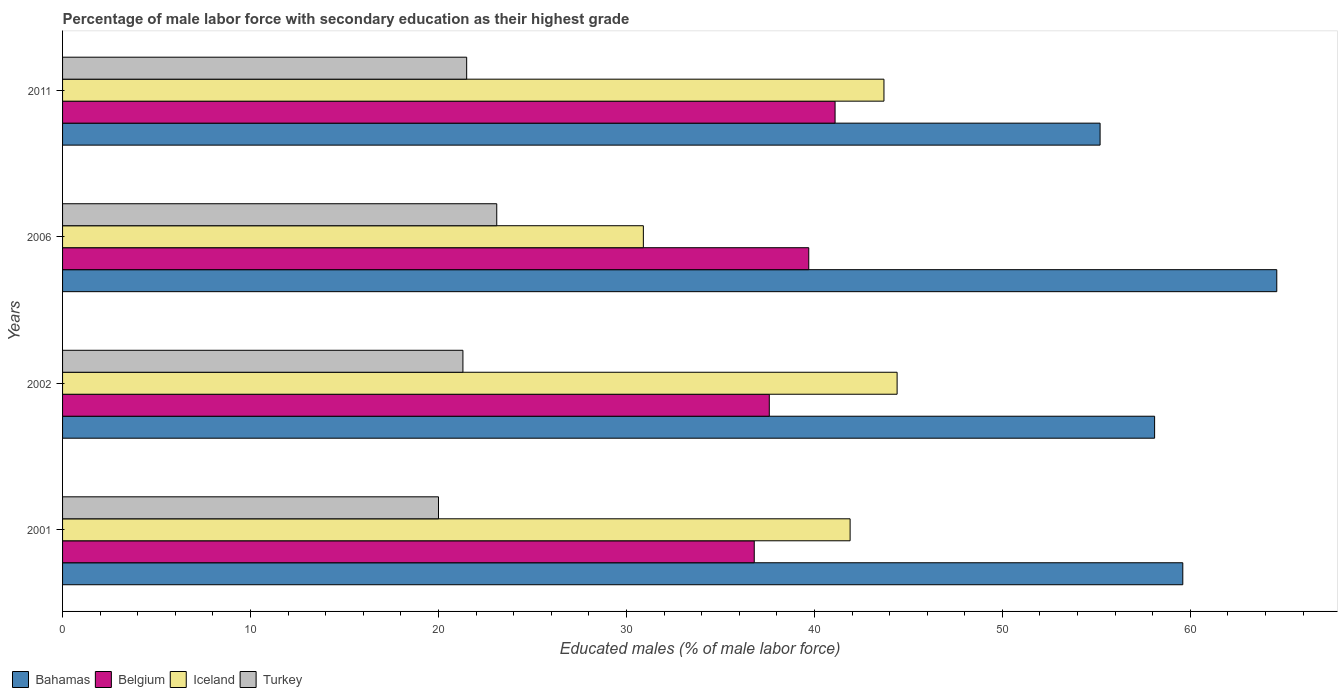Are the number of bars on each tick of the Y-axis equal?
Make the answer very short. Yes. How many bars are there on the 2nd tick from the top?
Offer a very short reply. 4. What is the percentage of male labor force with secondary education in Bahamas in 2011?
Your answer should be very brief. 55.2. Across all years, what is the maximum percentage of male labor force with secondary education in Belgium?
Provide a succinct answer. 41.1. What is the total percentage of male labor force with secondary education in Belgium in the graph?
Provide a succinct answer. 155.2. What is the difference between the percentage of male labor force with secondary education in Bahamas in 2001 and that in 2011?
Ensure brevity in your answer.  4.4. What is the difference between the percentage of male labor force with secondary education in Bahamas in 2006 and the percentage of male labor force with secondary education in Belgium in 2011?
Your answer should be compact. 23.5. What is the average percentage of male labor force with secondary education in Belgium per year?
Offer a terse response. 38.8. In the year 2001, what is the difference between the percentage of male labor force with secondary education in Bahamas and percentage of male labor force with secondary education in Turkey?
Make the answer very short. 39.6. In how many years, is the percentage of male labor force with secondary education in Iceland greater than 8 %?
Offer a very short reply. 4. What is the ratio of the percentage of male labor force with secondary education in Bahamas in 2001 to that in 2006?
Your answer should be compact. 0.92. Is the percentage of male labor force with secondary education in Iceland in 2001 less than that in 2006?
Your answer should be very brief. No. Is the difference between the percentage of male labor force with secondary education in Bahamas in 2006 and 2011 greater than the difference between the percentage of male labor force with secondary education in Turkey in 2006 and 2011?
Your answer should be very brief. Yes. What is the difference between the highest and the second highest percentage of male labor force with secondary education in Iceland?
Your response must be concise. 0.7. What is the difference between the highest and the lowest percentage of male labor force with secondary education in Bahamas?
Keep it short and to the point. 9.4. In how many years, is the percentage of male labor force with secondary education in Belgium greater than the average percentage of male labor force with secondary education in Belgium taken over all years?
Your answer should be compact. 2. What does the 3rd bar from the top in 2006 represents?
Your answer should be compact. Belgium. What does the 1st bar from the bottom in 2011 represents?
Ensure brevity in your answer.  Bahamas. How many bars are there?
Ensure brevity in your answer.  16. Are all the bars in the graph horizontal?
Give a very brief answer. Yes. What is the difference between two consecutive major ticks on the X-axis?
Make the answer very short. 10. Are the values on the major ticks of X-axis written in scientific E-notation?
Your answer should be compact. No. Does the graph contain grids?
Ensure brevity in your answer.  No. Where does the legend appear in the graph?
Ensure brevity in your answer.  Bottom left. What is the title of the graph?
Offer a terse response. Percentage of male labor force with secondary education as their highest grade. What is the label or title of the X-axis?
Your response must be concise. Educated males (% of male labor force). What is the label or title of the Y-axis?
Give a very brief answer. Years. What is the Educated males (% of male labor force) of Bahamas in 2001?
Your response must be concise. 59.6. What is the Educated males (% of male labor force) of Belgium in 2001?
Provide a short and direct response. 36.8. What is the Educated males (% of male labor force) of Iceland in 2001?
Ensure brevity in your answer.  41.9. What is the Educated males (% of male labor force) in Turkey in 2001?
Make the answer very short. 20. What is the Educated males (% of male labor force) of Bahamas in 2002?
Offer a terse response. 58.1. What is the Educated males (% of male labor force) in Belgium in 2002?
Make the answer very short. 37.6. What is the Educated males (% of male labor force) of Iceland in 2002?
Your response must be concise. 44.4. What is the Educated males (% of male labor force) in Turkey in 2002?
Offer a terse response. 21.3. What is the Educated males (% of male labor force) in Bahamas in 2006?
Give a very brief answer. 64.6. What is the Educated males (% of male labor force) of Belgium in 2006?
Ensure brevity in your answer.  39.7. What is the Educated males (% of male labor force) of Iceland in 2006?
Make the answer very short. 30.9. What is the Educated males (% of male labor force) of Turkey in 2006?
Make the answer very short. 23.1. What is the Educated males (% of male labor force) in Bahamas in 2011?
Your response must be concise. 55.2. What is the Educated males (% of male labor force) of Belgium in 2011?
Your answer should be compact. 41.1. What is the Educated males (% of male labor force) in Iceland in 2011?
Give a very brief answer. 43.7. Across all years, what is the maximum Educated males (% of male labor force) of Bahamas?
Keep it short and to the point. 64.6. Across all years, what is the maximum Educated males (% of male labor force) in Belgium?
Keep it short and to the point. 41.1. Across all years, what is the maximum Educated males (% of male labor force) in Iceland?
Your answer should be compact. 44.4. Across all years, what is the maximum Educated males (% of male labor force) in Turkey?
Your answer should be compact. 23.1. Across all years, what is the minimum Educated males (% of male labor force) of Bahamas?
Keep it short and to the point. 55.2. Across all years, what is the minimum Educated males (% of male labor force) in Belgium?
Offer a very short reply. 36.8. Across all years, what is the minimum Educated males (% of male labor force) of Iceland?
Keep it short and to the point. 30.9. What is the total Educated males (% of male labor force) of Bahamas in the graph?
Your response must be concise. 237.5. What is the total Educated males (% of male labor force) of Belgium in the graph?
Offer a very short reply. 155.2. What is the total Educated males (% of male labor force) in Iceland in the graph?
Give a very brief answer. 160.9. What is the total Educated males (% of male labor force) in Turkey in the graph?
Your answer should be compact. 85.9. What is the difference between the Educated males (% of male labor force) of Belgium in 2001 and that in 2002?
Provide a short and direct response. -0.8. What is the difference between the Educated males (% of male labor force) in Iceland in 2001 and that in 2002?
Your response must be concise. -2.5. What is the difference between the Educated males (% of male labor force) in Belgium in 2001 and that in 2006?
Your response must be concise. -2.9. What is the difference between the Educated males (% of male labor force) of Iceland in 2001 and that in 2006?
Provide a short and direct response. 11. What is the difference between the Educated males (% of male labor force) in Iceland in 2001 and that in 2011?
Provide a short and direct response. -1.8. What is the difference between the Educated males (% of male labor force) of Belgium in 2002 and that in 2006?
Your response must be concise. -2.1. What is the difference between the Educated males (% of male labor force) of Iceland in 2002 and that in 2006?
Your answer should be very brief. 13.5. What is the difference between the Educated males (% of male labor force) in Iceland in 2002 and that in 2011?
Offer a terse response. 0.7. What is the difference between the Educated males (% of male labor force) of Turkey in 2002 and that in 2011?
Offer a terse response. -0.2. What is the difference between the Educated males (% of male labor force) in Bahamas in 2006 and that in 2011?
Ensure brevity in your answer.  9.4. What is the difference between the Educated males (% of male labor force) of Belgium in 2006 and that in 2011?
Your answer should be very brief. -1.4. What is the difference between the Educated males (% of male labor force) of Iceland in 2006 and that in 2011?
Your answer should be very brief. -12.8. What is the difference between the Educated males (% of male labor force) in Turkey in 2006 and that in 2011?
Ensure brevity in your answer.  1.6. What is the difference between the Educated males (% of male labor force) of Bahamas in 2001 and the Educated males (% of male labor force) of Turkey in 2002?
Keep it short and to the point. 38.3. What is the difference between the Educated males (% of male labor force) of Iceland in 2001 and the Educated males (% of male labor force) of Turkey in 2002?
Your response must be concise. 20.6. What is the difference between the Educated males (% of male labor force) of Bahamas in 2001 and the Educated males (% of male labor force) of Iceland in 2006?
Provide a short and direct response. 28.7. What is the difference between the Educated males (% of male labor force) in Bahamas in 2001 and the Educated males (% of male labor force) in Turkey in 2006?
Your answer should be very brief. 36.5. What is the difference between the Educated males (% of male labor force) in Belgium in 2001 and the Educated males (% of male labor force) in Turkey in 2006?
Your answer should be very brief. 13.7. What is the difference between the Educated males (% of male labor force) of Bahamas in 2001 and the Educated males (% of male labor force) of Belgium in 2011?
Your answer should be very brief. 18.5. What is the difference between the Educated males (% of male labor force) of Bahamas in 2001 and the Educated males (% of male labor force) of Turkey in 2011?
Ensure brevity in your answer.  38.1. What is the difference between the Educated males (% of male labor force) in Belgium in 2001 and the Educated males (% of male labor force) in Iceland in 2011?
Provide a short and direct response. -6.9. What is the difference between the Educated males (% of male labor force) in Belgium in 2001 and the Educated males (% of male labor force) in Turkey in 2011?
Provide a succinct answer. 15.3. What is the difference between the Educated males (% of male labor force) in Iceland in 2001 and the Educated males (% of male labor force) in Turkey in 2011?
Your answer should be very brief. 20.4. What is the difference between the Educated males (% of male labor force) in Bahamas in 2002 and the Educated males (% of male labor force) in Iceland in 2006?
Your answer should be compact. 27.2. What is the difference between the Educated males (% of male labor force) in Bahamas in 2002 and the Educated males (% of male labor force) in Turkey in 2006?
Provide a short and direct response. 35. What is the difference between the Educated males (% of male labor force) in Belgium in 2002 and the Educated males (% of male labor force) in Iceland in 2006?
Offer a terse response. 6.7. What is the difference between the Educated males (% of male labor force) of Iceland in 2002 and the Educated males (% of male labor force) of Turkey in 2006?
Your answer should be very brief. 21.3. What is the difference between the Educated males (% of male labor force) of Bahamas in 2002 and the Educated males (% of male labor force) of Turkey in 2011?
Your answer should be compact. 36.6. What is the difference between the Educated males (% of male labor force) in Belgium in 2002 and the Educated males (% of male labor force) in Turkey in 2011?
Give a very brief answer. 16.1. What is the difference between the Educated males (% of male labor force) in Iceland in 2002 and the Educated males (% of male labor force) in Turkey in 2011?
Your answer should be very brief. 22.9. What is the difference between the Educated males (% of male labor force) of Bahamas in 2006 and the Educated males (% of male labor force) of Iceland in 2011?
Offer a terse response. 20.9. What is the difference between the Educated males (% of male labor force) of Bahamas in 2006 and the Educated males (% of male labor force) of Turkey in 2011?
Provide a short and direct response. 43.1. What is the average Educated males (% of male labor force) in Bahamas per year?
Offer a very short reply. 59.38. What is the average Educated males (% of male labor force) in Belgium per year?
Provide a short and direct response. 38.8. What is the average Educated males (% of male labor force) in Iceland per year?
Your answer should be compact. 40.23. What is the average Educated males (% of male labor force) of Turkey per year?
Provide a short and direct response. 21.48. In the year 2001, what is the difference between the Educated males (% of male labor force) in Bahamas and Educated males (% of male labor force) in Belgium?
Your answer should be compact. 22.8. In the year 2001, what is the difference between the Educated males (% of male labor force) in Bahamas and Educated males (% of male labor force) in Turkey?
Offer a terse response. 39.6. In the year 2001, what is the difference between the Educated males (% of male labor force) in Iceland and Educated males (% of male labor force) in Turkey?
Ensure brevity in your answer.  21.9. In the year 2002, what is the difference between the Educated males (% of male labor force) in Bahamas and Educated males (% of male labor force) in Turkey?
Provide a succinct answer. 36.8. In the year 2002, what is the difference between the Educated males (% of male labor force) in Belgium and Educated males (% of male labor force) in Turkey?
Offer a very short reply. 16.3. In the year 2002, what is the difference between the Educated males (% of male labor force) in Iceland and Educated males (% of male labor force) in Turkey?
Provide a succinct answer. 23.1. In the year 2006, what is the difference between the Educated males (% of male labor force) in Bahamas and Educated males (% of male labor force) in Belgium?
Offer a terse response. 24.9. In the year 2006, what is the difference between the Educated males (% of male labor force) of Bahamas and Educated males (% of male labor force) of Iceland?
Offer a very short reply. 33.7. In the year 2006, what is the difference between the Educated males (% of male labor force) of Bahamas and Educated males (% of male labor force) of Turkey?
Offer a terse response. 41.5. In the year 2006, what is the difference between the Educated males (% of male labor force) in Belgium and Educated males (% of male labor force) in Iceland?
Offer a very short reply. 8.8. In the year 2011, what is the difference between the Educated males (% of male labor force) in Bahamas and Educated males (% of male labor force) in Belgium?
Provide a short and direct response. 14.1. In the year 2011, what is the difference between the Educated males (% of male labor force) of Bahamas and Educated males (% of male labor force) of Iceland?
Ensure brevity in your answer.  11.5. In the year 2011, what is the difference between the Educated males (% of male labor force) of Bahamas and Educated males (% of male labor force) of Turkey?
Keep it short and to the point. 33.7. In the year 2011, what is the difference between the Educated males (% of male labor force) in Belgium and Educated males (% of male labor force) in Iceland?
Make the answer very short. -2.6. In the year 2011, what is the difference between the Educated males (% of male labor force) of Belgium and Educated males (% of male labor force) of Turkey?
Your answer should be very brief. 19.6. What is the ratio of the Educated males (% of male labor force) in Bahamas in 2001 to that in 2002?
Provide a short and direct response. 1.03. What is the ratio of the Educated males (% of male labor force) in Belgium in 2001 to that in 2002?
Your answer should be very brief. 0.98. What is the ratio of the Educated males (% of male labor force) in Iceland in 2001 to that in 2002?
Your response must be concise. 0.94. What is the ratio of the Educated males (% of male labor force) of Turkey in 2001 to that in 2002?
Keep it short and to the point. 0.94. What is the ratio of the Educated males (% of male labor force) of Bahamas in 2001 to that in 2006?
Offer a terse response. 0.92. What is the ratio of the Educated males (% of male labor force) in Belgium in 2001 to that in 2006?
Your response must be concise. 0.93. What is the ratio of the Educated males (% of male labor force) of Iceland in 2001 to that in 2006?
Keep it short and to the point. 1.36. What is the ratio of the Educated males (% of male labor force) in Turkey in 2001 to that in 2006?
Your answer should be very brief. 0.87. What is the ratio of the Educated males (% of male labor force) in Bahamas in 2001 to that in 2011?
Your answer should be compact. 1.08. What is the ratio of the Educated males (% of male labor force) of Belgium in 2001 to that in 2011?
Offer a very short reply. 0.9. What is the ratio of the Educated males (% of male labor force) in Iceland in 2001 to that in 2011?
Your response must be concise. 0.96. What is the ratio of the Educated males (% of male labor force) of Turkey in 2001 to that in 2011?
Make the answer very short. 0.93. What is the ratio of the Educated males (% of male labor force) of Bahamas in 2002 to that in 2006?
Your response must be concise. 0.9. What is the ratio of the Educated males (% of male labor force) in Belgium in 2002 to that in 2006?
Your response must be concise. 0.95. What is the ratio of the Educated males (% of male labor force) in Iceland in 2002 to that in 2006?
Ensure brevity in your answer.  1.44. What is the ratio of the Educated males (% of male labor force) of Turkey in 2002 to that in 2006?
Offer a very short reply. 0.92. What is the ratio of the Educated males (% of male labor force) of Bahamas in 2002 to that in 2011?
Give a very brief answer. 1.05. What is the ratio of the Educated males (% of male labor force) of Belgium in 2002 to that in 2011?
Make the answer very short. 0.91. What is the ratio of the Educated males (% of male labor force) in Iceland in 2002 to that in 2011?
Provide a succinct answer. 1.02. What is the ratio of the Educated males (% of male labor force) of Turkey in 2002 to that in 2011?
Your answer should be compact. 0.99. What is the ratio of the Educated males (% of male labor force) of Bahamas in 2006 to that in 2011?
Ensure brevity in your answer.  1.17. What is the ratio of the Educated males (% of male labor force) in Belgium in 2006 to that in 2011?
Offer a very short reply. 0.97. What is the ratio of the Educated males (% of male labor force) in Iceland in 2006 to that in 2011?
Provide a succinct answer. 0.71. What is the ratio of the Educated males (% of male labor force) in Turkey in 2006 to that in 2011?
Provide a short and direct response. 1.07. What is the difference between the highest and the lowest Educated males (% of male labor force) in Bahamas?
Keep it short and to the point. 9.4. What is the difference between the highest and the lowest Educated males (% of male labor force) of Iceland?
Provide a succinct answer. 13.5. What is the difference between the highest and the lowest Educated males (% of male labor force) of Turkey?
Give a very brief answer. 3.1. 